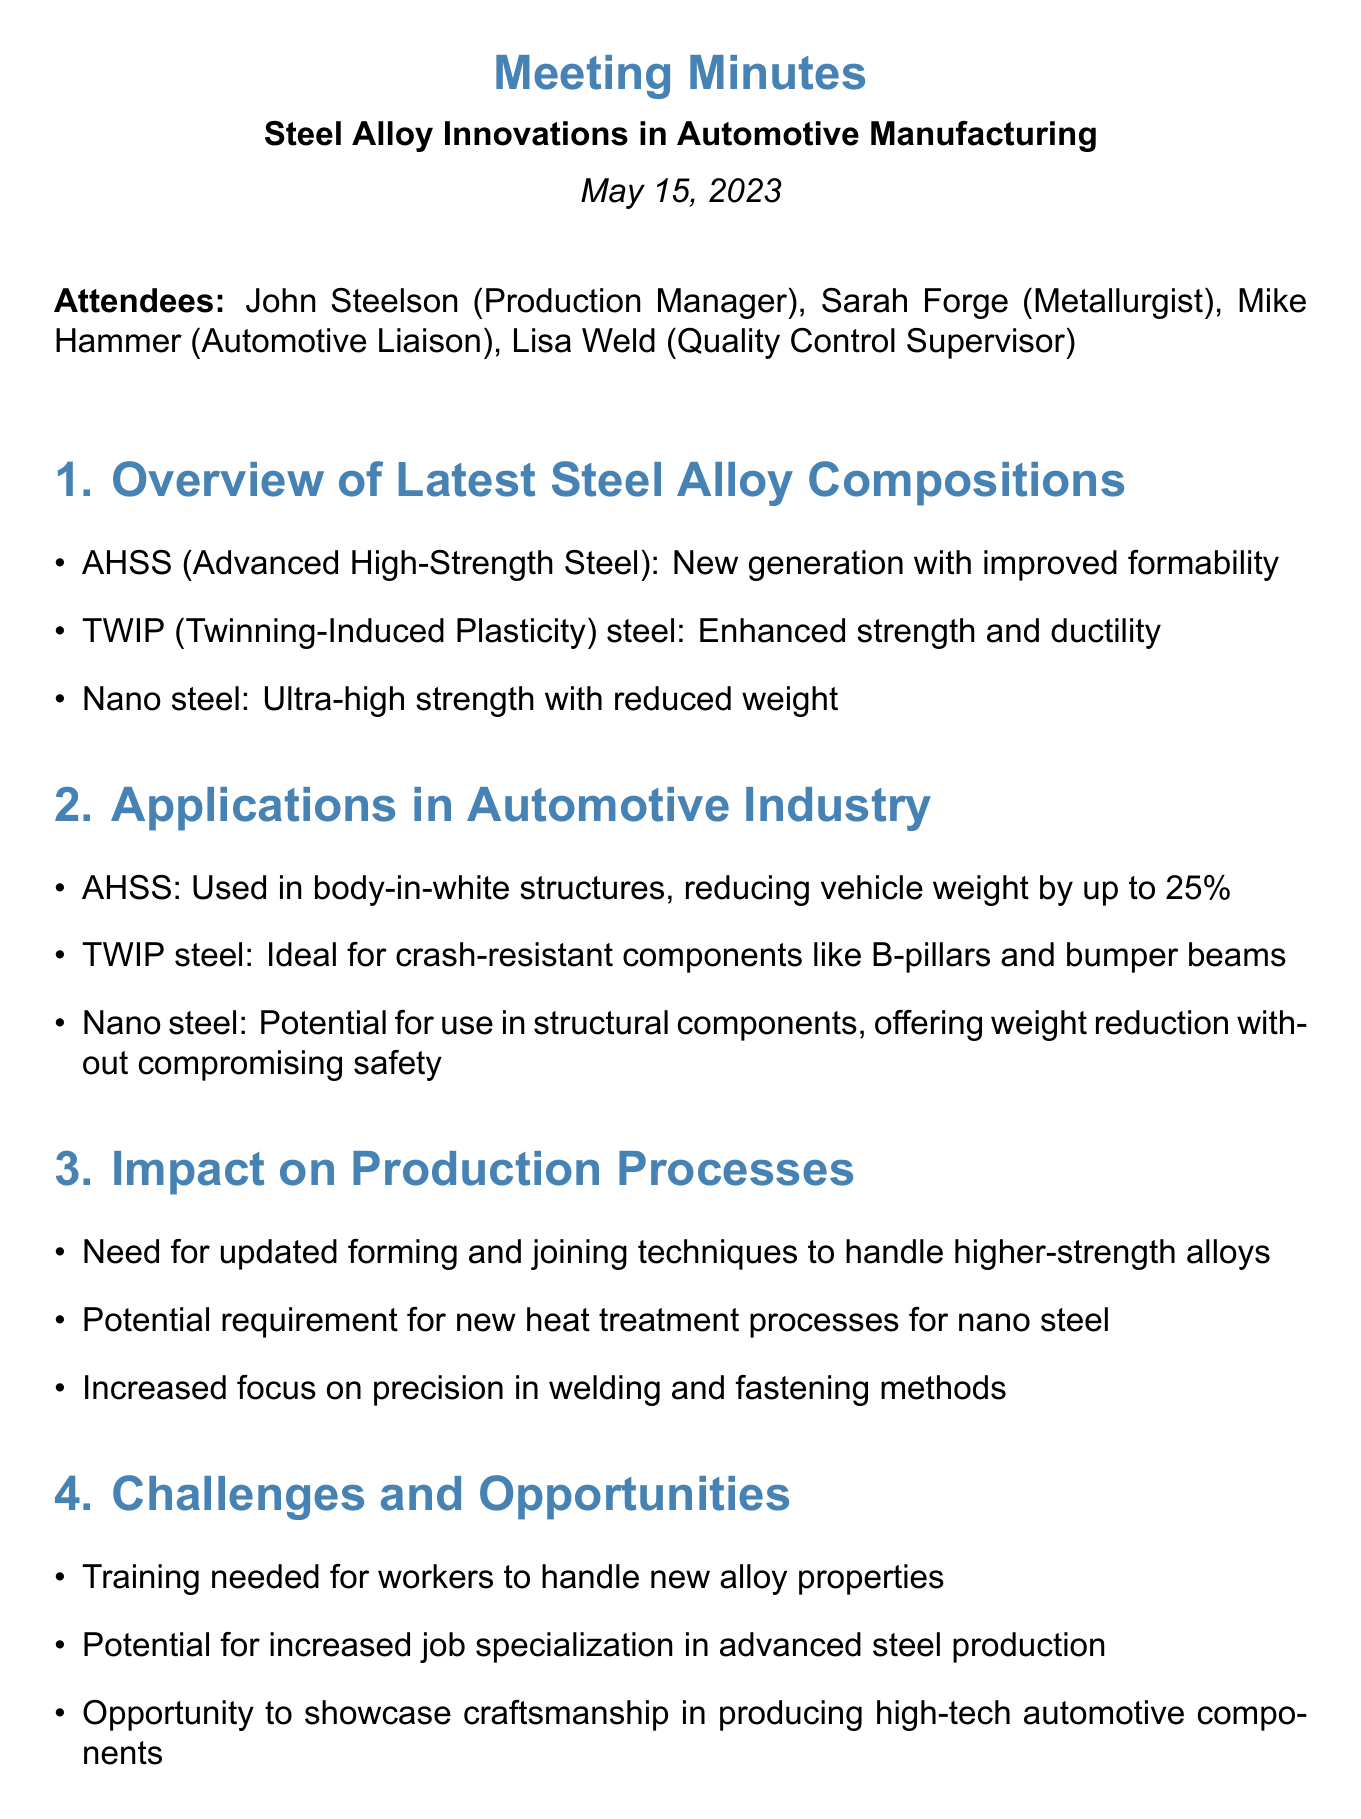What is the date of the meeting? The date of the meeting is stated at the beginning of the document.
Answer: May 15, 2023 Who is the Metallurgist in the meeting? The attendees list includes the names and roles of the participants.
Answer: Sarah Forge What is the potential weight reduction percentage of AHSS in vehicles? The document specifies the impact of AHSS on vehicle weight in the applications section.
Answer: up to 25% What are the new forming techniques related to? The impact on production processes section mentions new techniques needed for a specific purpose.
Answer: Higher-strength alloys Which steel is ideal for crash-resistant components? The applications section identifies the best material for specific automotive components.
Answer: TWIP steel What is one challenge mentioned regarding the new alloy properties? The challenges section lists a specific challenge that needs addressing for workers.
Answer: Training needed What company is mentioned for collaboration on AHSS implementation? The next steps section lists a specific company for a collaboration effort.
Answer: ArcelorMittal What is the focus in welding methods stated in the document? The impact on production processes section highlights the emphasis needed in a particular area.
Answer: Precision 